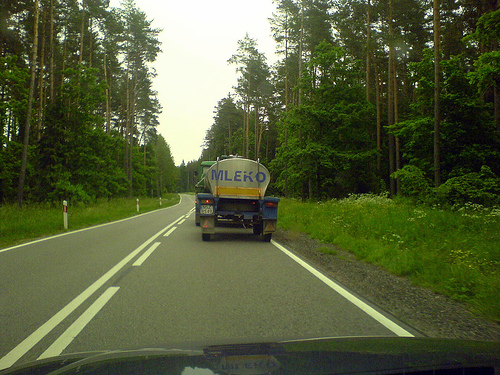<image>
Can you confirm if the truck is on the grass? No. The truck is not positioned on the grass. They may be near each other, but the truck is not supported by or resting on top of the grass. Is the truck in the tree? No. The truck is not contained within the tree. These objects have a different spatial relationship. 